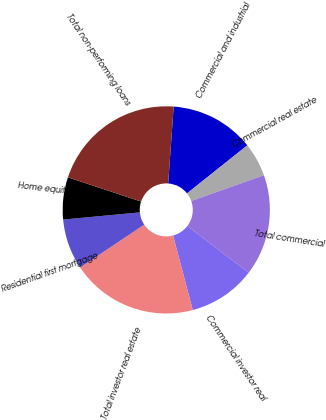Convert chart. <chart><loc_0><loc_0><loc_500><loc_500><pie_chart><fcel>Commercial and industrial<fcel>Commercial real estate<fcel>Total commercial<fcel>Commercial investor real<fcel>Total investor real estate<fcel>Residential first mortgage<fcel>Home equity<fcel>Total non-performing loans<nl><fcel>13.16%<fcel>5.27%<fcel>15.79%<fcel>10.53%<fcel>19.73%<fcel>7.9%<fcel>6.58%<fcel>21.05%<nl></chart> 